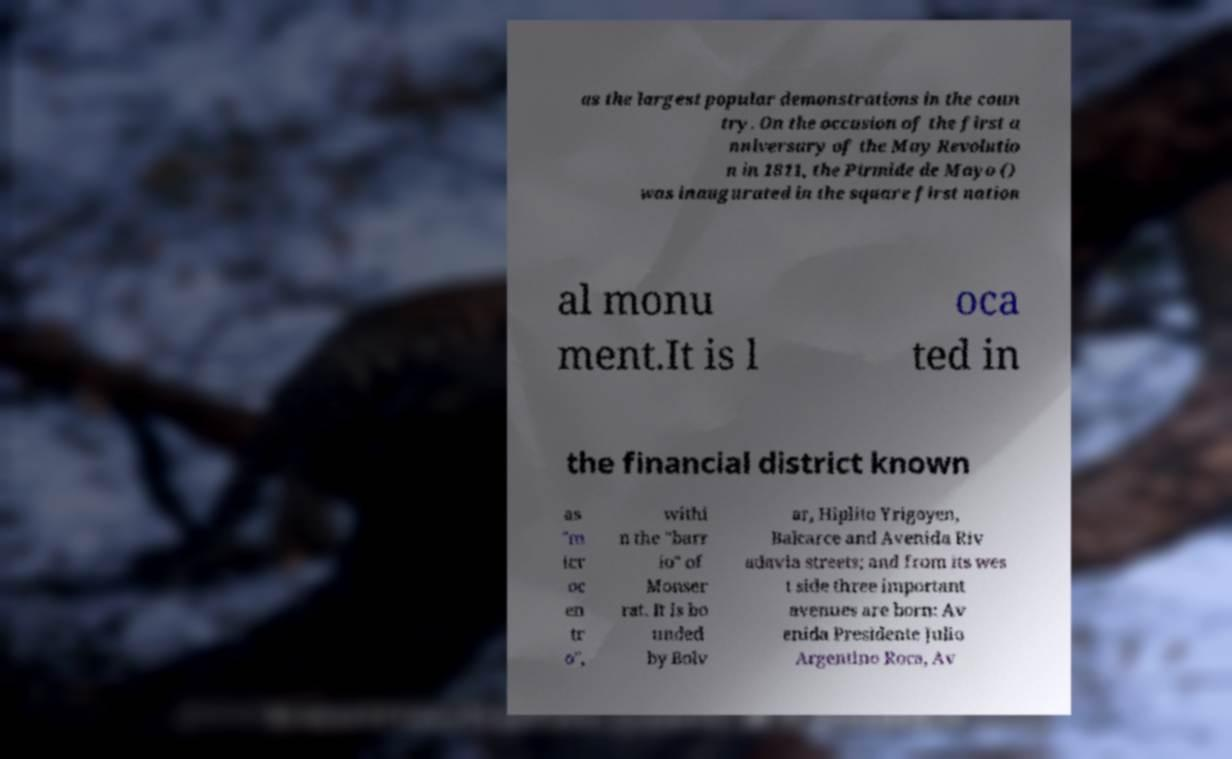Please read and relay the text visible in this image. What does it say? as the largest popular demonstrations in the coun try. On the occasion of the first a nniversary of the May Revolutio n in 1811, the Pirmide de Mayo () was inaugurated in the square first nation al monu ment.It is l oca ted in the financial district known as "m icr oc en tr o", withi n the "barr io" of Monser rat. It is bo unded by Bolv ar, Hiplito Yrigoyen, Balcarce and Avenida Riv adavia streets; and from its wes t side three important avenues are born: Av enida Presidente Julio Argentino Roca, Av 